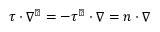Convert formula to latex. <formula><loc_0><loc_0><loc_500><loc_500>\tau \cdot \nabla ^ { \perp } = - \tau ^ { \perp } \cdot \nabla = n \cdot \nabla</formula> 